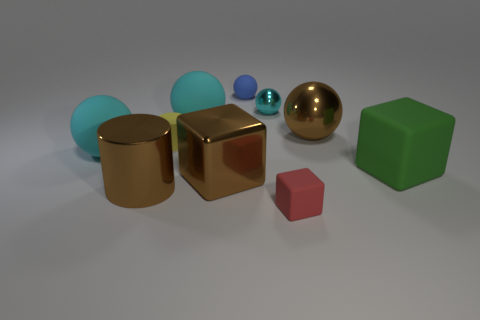Subtract all cyan balls. How many were subtracted if there are1cyan balls left? 2 Subtract all blue matte balls. How many balls are left? 4 Subtract all brown spheres. How many spheres are left? 4 Subtract all red blocks. How many cyan balls are left? 3 Subtract 2 spheres. How many spheres are left? 3 Subtract all cylinders. How many objects are left? 8 Subtract all purple spheres. Subtract all green cubes. How many spheres are left? 5 Subtract all large green shiny blocks. Subtract all big brown shiny cylinders. How many objects are left? 9 Add 8 tiny cubes. How many tiny cubes are left? 9 Add 6 small green spheres. How many small green spheres exist? 6 